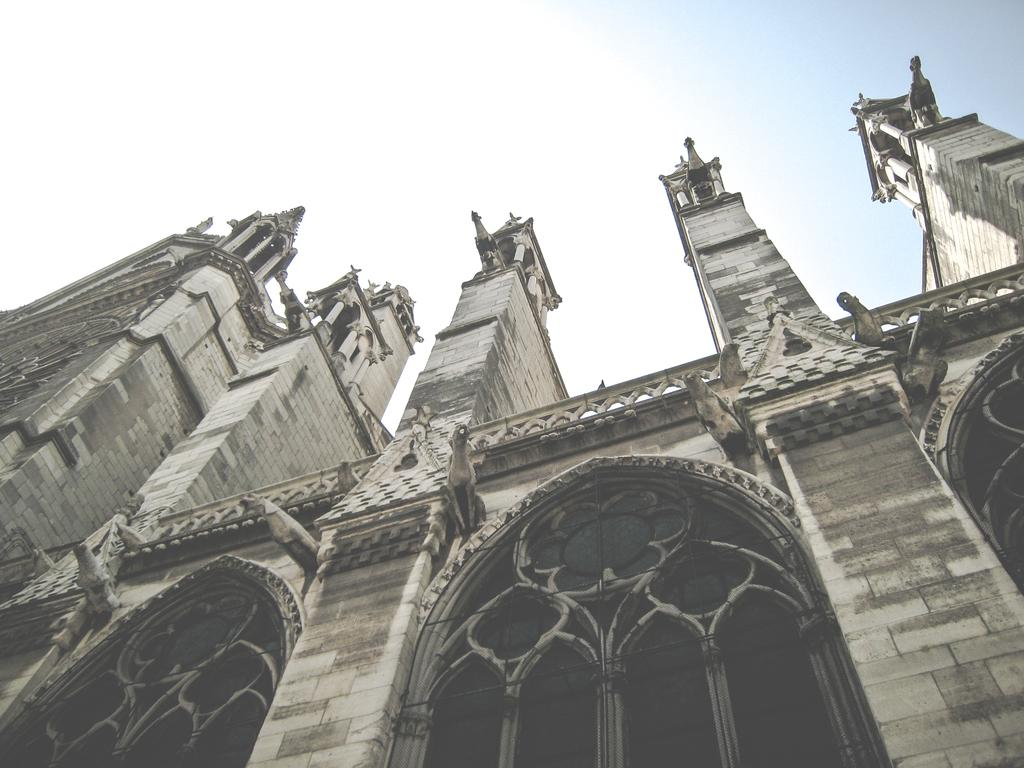What type of structure is present in the image? There is a building in the image. What can be seen above the building in the image? The sky is visible at the top of the image. What month is the mother celebrating her birthday in the image? There is no mother or birthday celebration present in the image; it only features a building and the sky. 